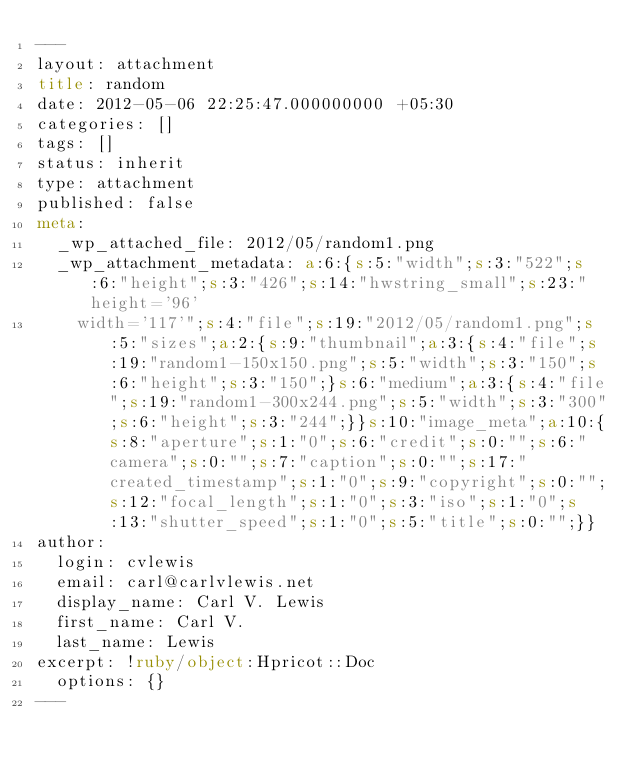Convert code to text. <code><loc_0><loc_0><loc_500><loc_500><_HTML_>---
layout: attachment
title: random
date: 2012-05-06 22:25:47.000000000 +05:30
categories: []
tags: []
status: inherit
type: attachment
published: false
meta:
  _wp_attached_file: 2012/05/random1.png
  _wp_attachment_metadata: a:6:{s:5:"width";s:3:"522";s:6:"height";s:3:"426";s:14:"hwstring_small";s:23:"height='96'
    width='117'";s:4:"file";s:19:"2012/05/random1.png";s:5:"sizes";a:2:{s:9:"thumbnail";a:3:{s:4:"file";s:19:"random1-150x150.png";s:5:"width";s:3:"150";s:6:"height";s:3:"150";}s:6:"medium";a:3:{s:4:"file";s:19:"random1-300x244.png";s:5:"width";s:3:"300";s:6:"height";s:3:"244";}}s:10:"image_meta";a:10:{s:8:"aperture";s:1:"0";s:6:"credit";s:0:"";s:6:"camera";s:0:"";s:7:"caption";s:0:"";s:17:"created_timestamp";s:1:"0";s:9:"copyright";s:0:"";s:12:"focal_length";s:1:"0";s:3:"iso";s:1:"0";s:13:"shutter_speed";s:1:"0";s:5:"title";s:0:"";}}
author:
  login: cvlewis
  email: carl@carlvlewis.net
  display_name: Carl V. Lewis
  first_name: Carl V.
  last_name: Lewis
excerpt: !ruby/object:Hpricot::Doc
  options: {}
---

</code> 